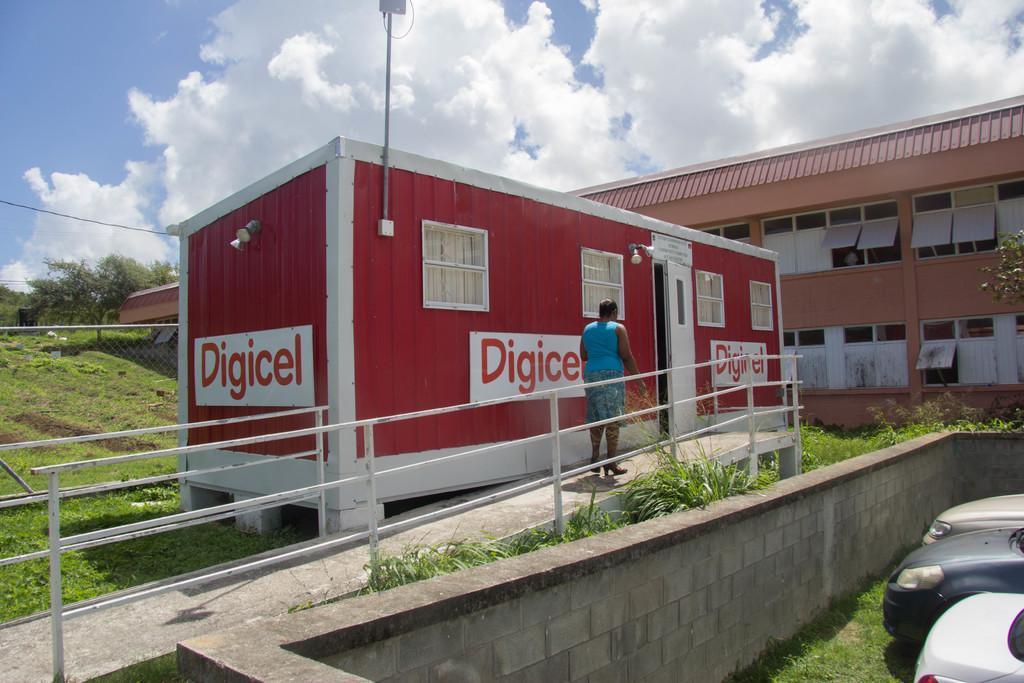Please provide a concise description of this image. In this picture I can see vehicles, grass, plants, iron rods, there is a person standing, there is wire fence, there are trees, this is looking like a shed, this is looking like a house, and in the background there is sky. 